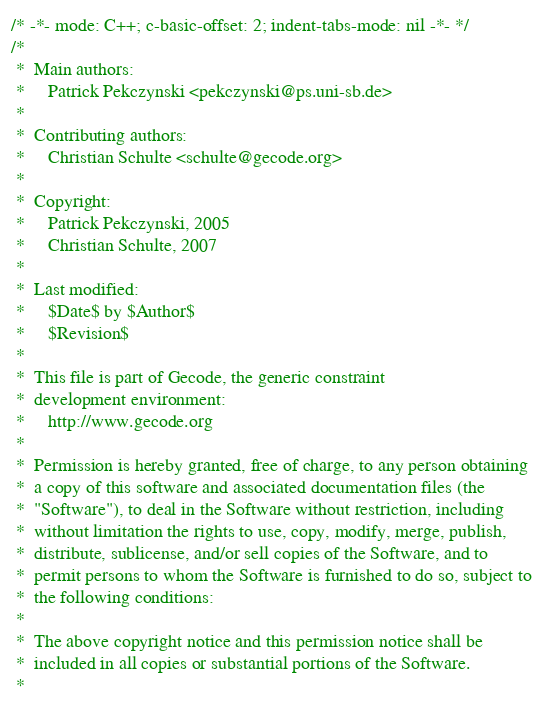Convert code to text. <code><loc_0><loc_0><loc_500><loc_500><_C++_>/* -*- mode: C++; c-basic-offset: 2; indent-tabs-mode: nil -*- */
/*
 *  Main authors:
 *     Patrick Pekczynski <pekczynski@ps.uni-sb.de>
 *
 *  Contributing authors:
 *     Christian Schulte <schulte@gecode.org>
 *
 *  Copyright:
 *     Patrick Pekczynski, 2005
 *     Christian Schulte, 2007
 *
 *  Last modified:
 *     $Date$ by $Author$
 *     $Revision$
 *
 *  This file is part of Gecode, the generic constraint
 *  development environment:
 *     http://www.gecode.org
 *
 *  Permission is hereby granted, free of charge, to any person obtaining
 *  a copy of this software and associated documentation files (the
 *  "Software"), to deal in the Software without restriction, including
 *  without limitation the rights to use, copy, modify, merge, publish,
 *  distribute, sublicense, and/or sell copies of the Software, and to
 *  permit persons to whom the Software is furnished to do so, subject to
 *  the following conditions:
 *
 *  The above copyright notice and this permission notice shall be
 *  included in all copies or substantial portions of the Software.
 *</code> 